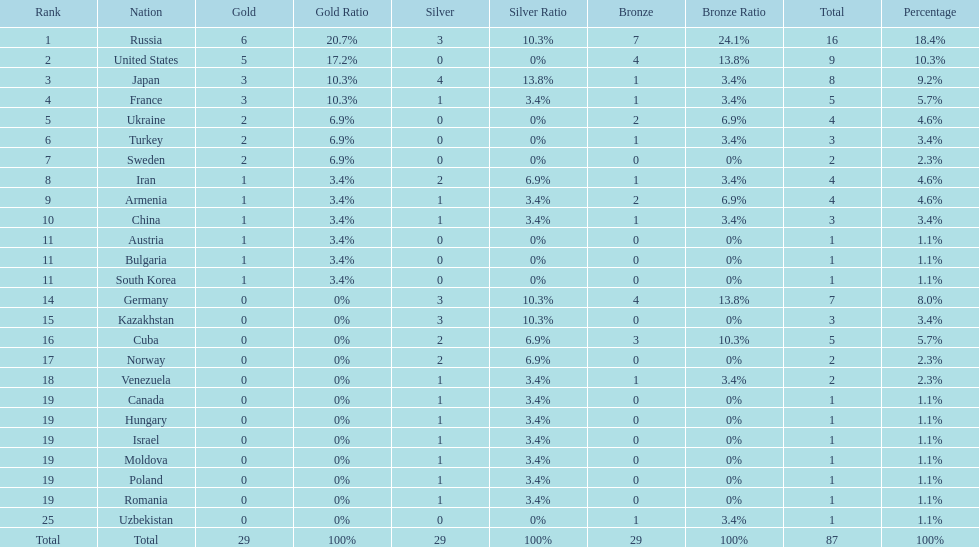Which nation was not in the top 10 iran or germany? Germany. 